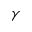<formula> <loc_0><loc_0><loc_500><loc_500>\gamma</formula> 